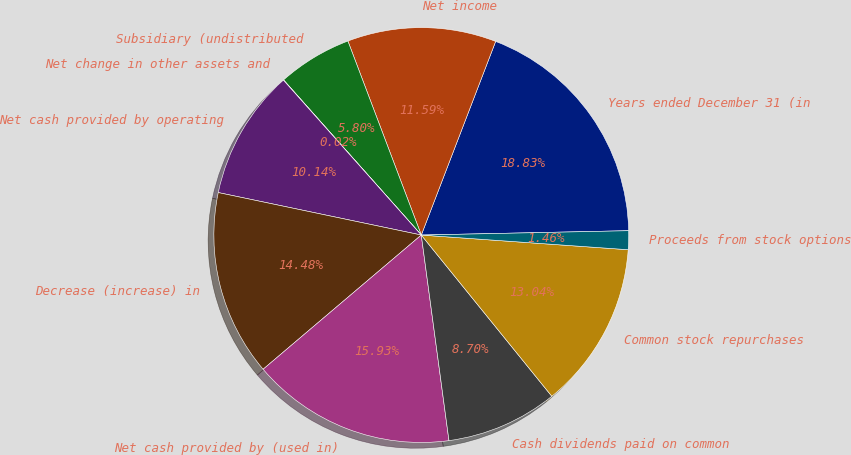Convert chart. <chart><loc_0><loc_0><loc_500><loc_500><pie_chart><fcel>Years ended December 31 (in<fcel>Net income<fcel>Subsidiary (undistributed<fcel>Net change in other assets and<fcel>Net cash provided by operating<fcel>Decrease (increase) in<fcel>Net cash provided by (used in)<fcel>Cash dividends paid on common<fcel>Common stock repurchases<fcel>Proceeds from stock options<nl><fcel>18.83%<fcel>11.59%<fcel>5.8%<fcel>0.02%<fcel>10.14%<fcel>14.48%<fcel>15.93%<fcel>8.7%<fcel>13.04%<fcel>1.46%<nl></chart> 